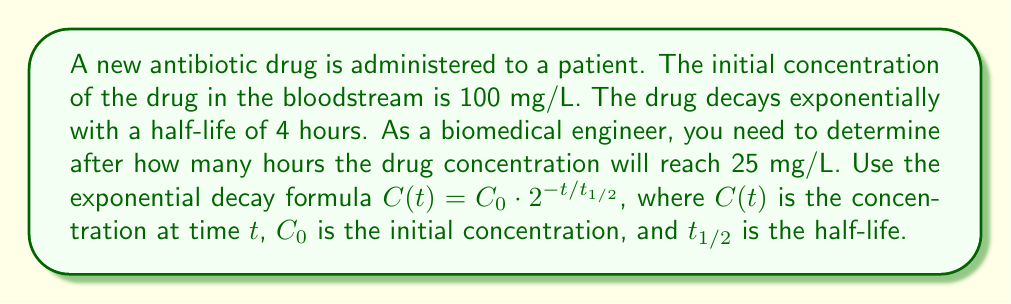Could you help me with this problem? Let's solve this step-by-step:

1) We're given:
   $C_0 = 100$ mg/L (initial concentration)
   $t_{1/2} = 4$ hours (half-life)
   $C(t) = 25$ mg/L (target concentration)

2) We need to find $t$. Let's use the exponential decay formula:

   $C(t) = C_0 \cdot 2^{-t/t_{1/2}}$

3) Substitute the known values:

   $25 = 100 \cdot 2^{-t/4}$

4) Divide both sides by 100:

   $\frac{1}{4} = 2^{-t/4}$

5) Take the logarithm (base 2) of both sides:

   $\log_2(\frac{1}{4}) = \log_2(2^{-t/4})$

6) Simplify the right side using the logarithm property $\log_a(a^x) = x$:

   $\log_2(\frac{1}{4}) = -\frac{t}{4}$

7) Simplify the left side:

   $-2 = -\frac{t}{4}$

8) Multiply both sides by -4:

   $8 = t$

Therefore, it will take 8 hours for the drug concentration to reach 25 mg/L.
Answer: 8 hours 